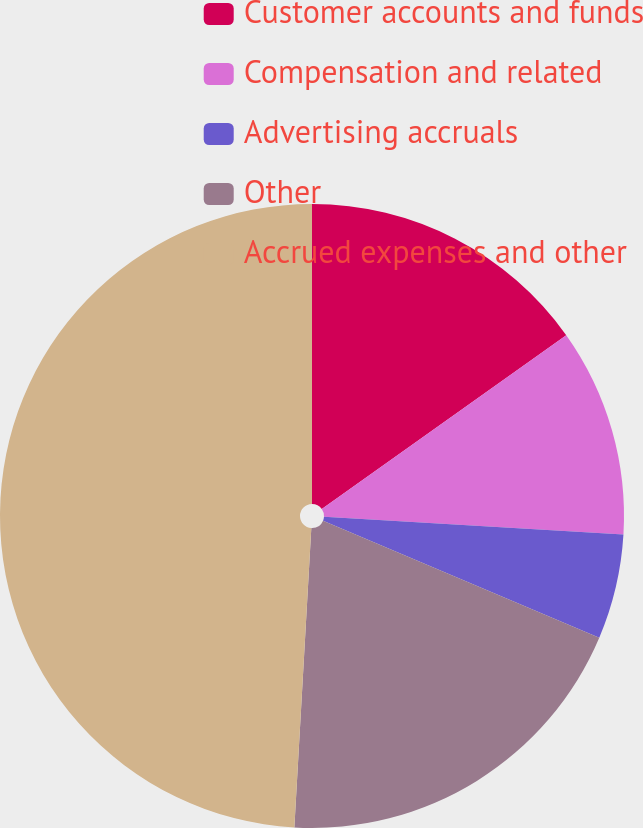Convert chart. <chart><loc_0><loc_0><loc_500><loc_500><pie_chart><fcel>Customer accounts and funds<fcel>Compensation and related<fcel>Advertising accruals<fcel>Other<fcel>Accrued expenses and other<nl><fcel>15.16%<fcel>10.79%<fcel>5.43%<fcel>19.52%<fcel>49.1%<nl></chart> 